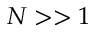<formula> <loc_0><loc_0><loc_500><loc_500>N > > 1</formula> 